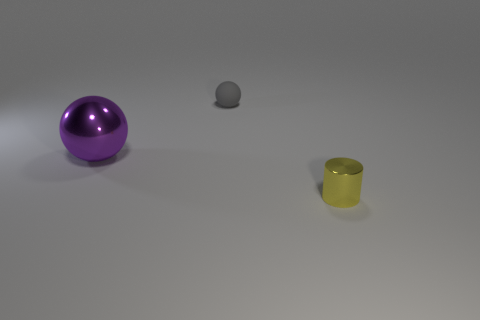How many other things are there of the same material as the purple ball?
Offer a very short reply. 1. What number of objects are either large brown metallic cubes or matte things left of the small yellow shiny cylinder?
Make the answer very short. 1. Are there fewer large cyan blocks than tiny balls?
Your response must be concise. Yes. The tiny thing in front of the ball behind the object on the left side of the small gray rubber sphere is what color?
Give a very brief answer. Yellow. Are the tiny yellow cylinder and the purple object made of the same material?
Keep it short and to the point. Yes. What number of tiny objects are to the right of the metal sphere?
Give a very brief answer. 2. What size is the other thing that is the same shape as the small gray object?
Provide a succinct answer. Large. How many cyan things are either cylinders or small matte things?
Your answer should be very brief. 0. What number of small yellow metal cylinders are to the left of the thing behind the big purple thing?
Keep it short and to the point. 0. What number of other objects are the same shape as the small gray rubber thing?
Provide a succinct answer. 1. 